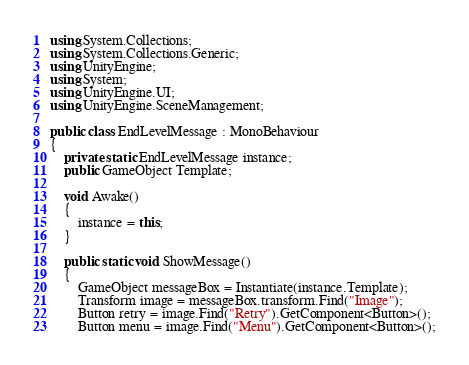<code> <loc_0><loc_0><loc_500><loc_500><_C#_>using System.Collections;
using System.Collections.Generic;
using UnityEngine;
using System;
using UnityEngine.UI;
using UnityEngine.SceneManagement;

public class EndLevelMessage : MonoBehaviour
{
    private static EndLevelMessage instance;
    public GameObject Template;

    void Awake()
    {
        instance = this;
    }

    public static void ShowMessage()
    {
        GameObject messageBox = Instantiate(instance.Template);
        Transform image = messageBox.transform.Find("Image");
        Button retry = image.Find("Retry").GetComponent<Button>();
        Button menu = image.Find("Menu").GetComponent<Button>();</code> 